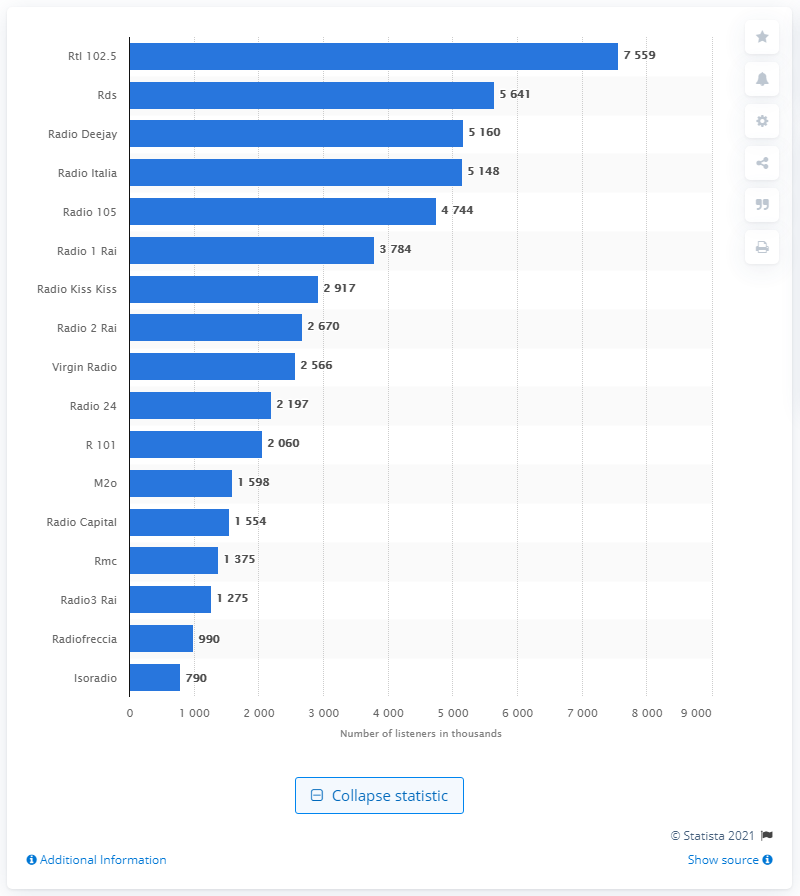Mention a couple of crucial points in this snapshot. RDS, an Italian radio station, had the highest number of daily listeners among all other radio stations in Italy. 